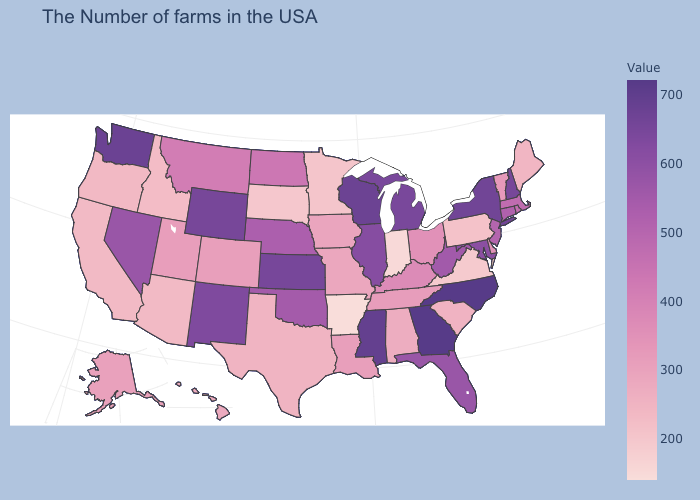Among the states that border Connecticut , does Rhode Island have the lowest value?
Answer briefly. Yes. Does Washington have the highest value in the West?
Short answer required. Yes. Does Wisconsin have the highest value in the MidWest?
Be succinct. Yes. Is the legend a continuous bar?
Give a very brief answer. Yes. Is the legend a continuous bar?
Give a very brief answer. Yes. Does Pennsylvania have the lowest value in the Northeast?
Concise answer only. Yes. Does Arkansas have the lowest value in the USA?
Quick response, please. Yes. 